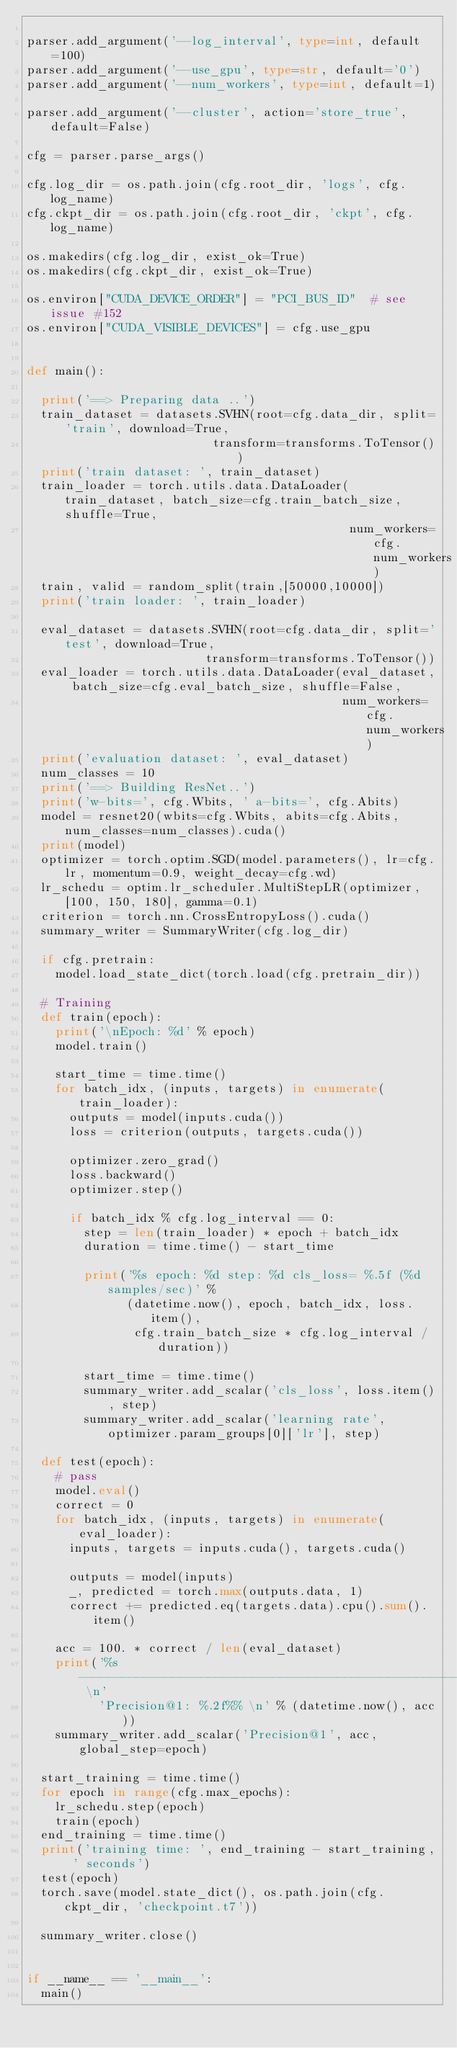Convert code to text. <code><loc_0><loc_0><loc_500><loc_500><_Python_>
parser.add_argument('--log_interval', type=int, default=100)
parser.add_argument('--use_gpu', type=str, default='0')
parser.add_argument('--num_workers', type=int, default=1)

parser.add_argument('--cluster', action='store_true', default=False)

cfg = parser.parse_args()

cfg.log_dir = os.path.join(cfg.root_dir, 'logs', cfg.log_name)
cfg.ckpt_dir = os.path.join(cfg.root_dir, 'ckpt', cfg.log_name)

os.makedirs(cfg.log_dir, exist_ok=True)
os.makedirs(cfg.ckpt_dir, exist_ok=True)

os.environ["CUDA_DEVICE_ORDER"] = "PCI_BUS_ID"  # see issue #152
os.environ["CUDA_VISIBLE_DEVICES"] = cfg.use_gpu


def main():

  print('==> Preparing data ..')
  train_dataset = datasets.SVHN(root=cfg.data_dir, split='train', download=True,
                          transform=transforms.ToTensor())
  print('train dataset: ', train_dataset)
  train_loader = torch.utils.data.DataLoader(train_dataset, batch_size=cfg.train_batch_size, shuffle=True,
                                             num_workers=cfg.num_workers)
  train, valid = random_split(train,[50000,10000])
  print('train loader: ', train_loader)

  eval_dataset = datasets.SVHN(root=cfg.data_dir, split='test', download=True,
                         transform=transforms.ToTensor())
  eval_loader = torch.utils.data.DataLoader(eval_dataset, batch_size=cfg.eval_batch_size, shuffle=False,
                                            num_workers=cfg.num_workers)
  print('evaluation dataset: ', eval_dataset)
  num_classes = 10
  print('==> Building ResNet..')
  print('w-bits=', cfg.Wbits, ' a-bits=', cfg.Abits)
  model = resnet20(wbits=cfg.Wbits, abits=cfg.Abits, num_classes=num_classes).cuda()
  print(model)
  optimizer = torch.optim.SGD(model.parameters(), lr=cfg.lr, momentum=0.9, weight_decay=cfg.wd)
  lr_schedu = optim.lr_scheduler.MultiStepLR(optimizer, [100, 150, 180], gamma=0.1)
  criterion = torch.nn.CrossEntropyLoss().cuda()
  summary_writer = SummaryWriter(cfg.log_dir)

  if cfg.pretrain:
    model.load_state_dict(torch.load(cfg.pretrain_dir))

  # Training
  def train(epoch):
    print('\nEpoch: %d' % epoch)
    model.train()

    start_time = time.time()
    for batch_idx, (inputs, targets) in enumerate(train_loader):
      outputs = model(inputs.cuda())
      loss = criterion(outputs, targets.cuda())

      optimizer.zero_grad()
      loss.backward()
      optimizer.step()

      if batch_idx % cfg.log_interval == 0:
        step = len(train_loader) * epoch + batch_idx
        duration = time.time() - start_time

        print('%s epoch: %d step: %d cls_loss= %.5f (%d samples/sec)' %
              (datetime.now(), epoch, batch_idx, loss.item(),
               cfg.train_batch_size * cfg.log_interval / duration))

        start_time = time.time()
        summary_writer.add_scalar('cls_loss', loss.item(), step)
        summary_writer.add_scalar('learning rate', optimizer.param_groups[0]['lr'], step)

  def test(epoch):
    # pass
    model.eval()
    correct = 0
    for batch_idx, (inputs, targets) in enumerate(eval_loader):
      inputs, targets = inputs.cuda(), targets.cuda()

      outputs = model(inputs)
      _, predicted = torch.max(outputs.data, 1)
      correct += predicted.eq(targets.data).cpu().sum().item()

    acc = 100. * correct / len(eval_dataset)
    print('%s------------------------------------------------------ \n'
          'Precision@1: %.2f%% \n' % (datetime.now(), acc))
    summary_writer.add_scalar('Precision@1', acc, global_step=epoch)

  start_training = time.time()
  for epoch in range(cfg.max_epochs):
    lr_schedu.step(epoch)
    train(epoch)
  end_training = time.time()
  print('training time: ', end_training - start_training, ' seconds')
  test(epoch)
  torch.save(model.state_dict(), os.path.join(cfg.ckpt_dir, 'checkpoint.t7'))

  summary_writer.close()


if __name__ == '__main__':
  main()
</code> 